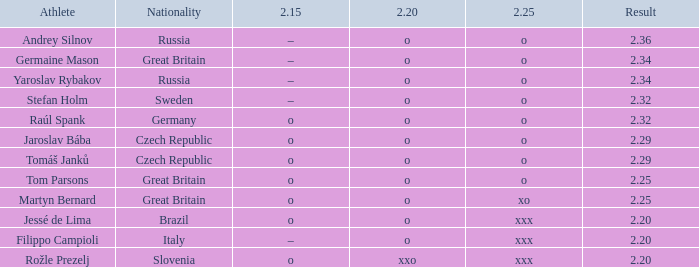Which athlete from Germany has 2.20 of O and a 2.25 of O? Raúl Spank. Could you help me parse every detail presented in this table? {'header': ['Athlete', 'Nationality', '2.15', '2.20', '2.25', 'Result'], 'rows': [['Andrey Silnov', 'Russia', '–', 'o', 'o', '2.36'], ['Germaine Mason', 'Great Britain', '–', 'o', 'o', '2.34'], ['Yaroslav Rybakov', 'Russia', '–', 'o', 'o', '2.34'], ['Stefan Holm', 'Sweden', '–', 'o', 'o', '2.32'], ['Raúl Spank', 'Germany', 'o', 'o', 'o', '2.32'], ['Jaroslav Bába', 'Czech Republic', 'o', 'o', 'o', '2.29'], ['Tomáš Janků', 'Czech Republic', 'o', 'o', 'o', '2.29'], ['Tom Parsons', 'Great Britain', 'o', 'o', 'o', '2.25'], ['Martyn Bernard', 'Great Britain', 'o', 'o', 'xo', '2.25'], ['Jessé de Lima', 'Brazil', 'o', 'o', 'xxx', '2.20'], ['Filippo Campioli', 'Italy', '–', 'o', 'xxx', '2.20'], ['Rožle Prezelj', 'Slovenia', 'o', 'xxo', 'xxx', '2.20']]} 